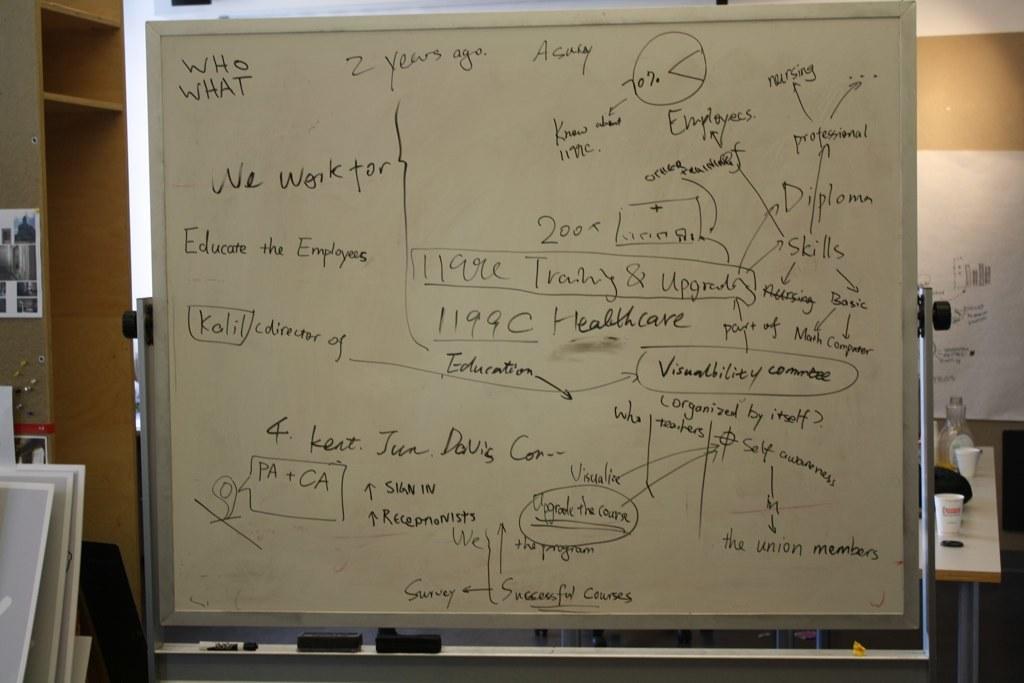In one or two sentences, can you explain what this image depicts? As we can see in the image there are shelves, photo frame, table and a white color wall. On table there are glasses. 